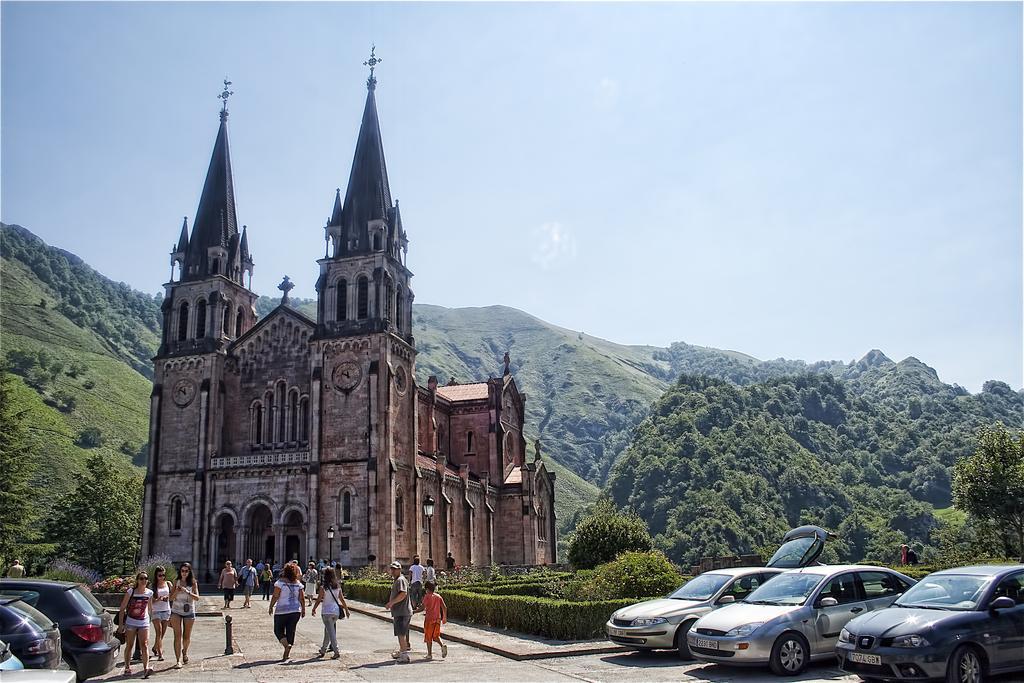Could you give a brief overview of what you see in this image? At the bottom of the picture, we see people walking on the road. On either side of the picture, we see cars parked on the road. On the right side, we see the shrubs and trees. In the middle of the picture, we see the castle and the church. There are trees and hills in the background. At the top, we see the sky and it is a sunny day. 